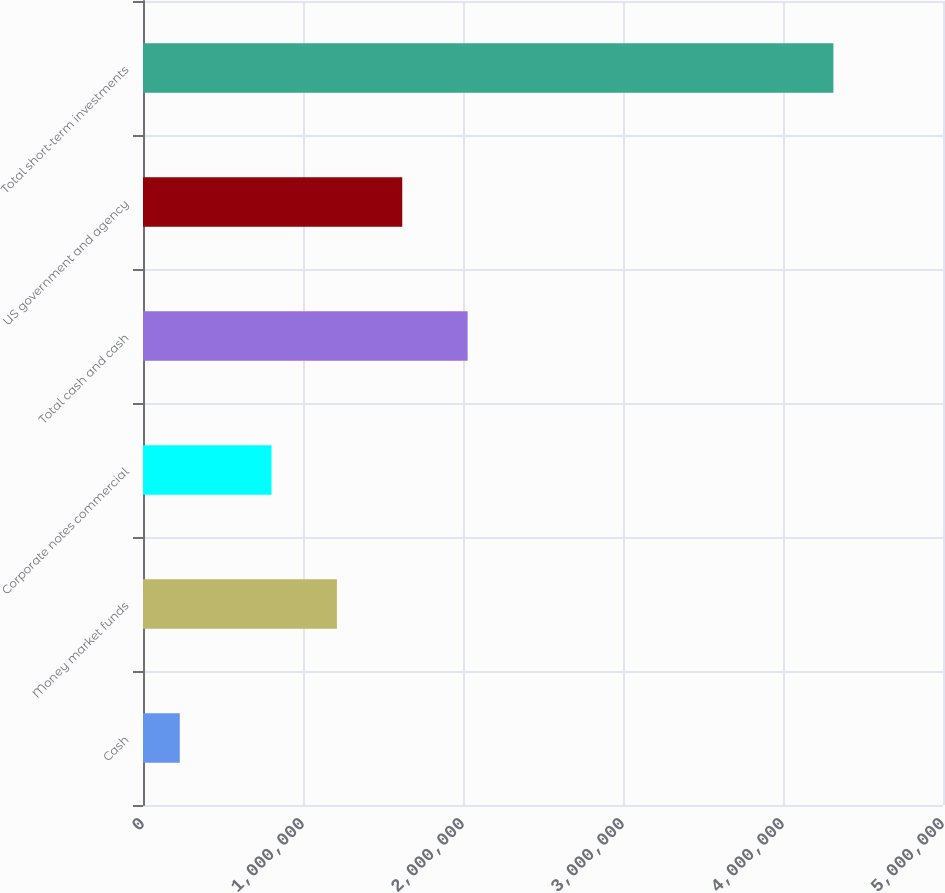Convert chart. <chart><loc_0><loc_0><loc_500><loc_500><bar_chart><fcel>Cash<fcel>Money market funds<fcel>Corporate notes commercial<fcel>Total cash and cash<fcel>US government and agency<fcel>Total short-term investments<nl><fcel>229924<fcel>1.21182e+06<fcel>803314<fcel>2.02882e+06<fcel>1.62032e+06<fcel>4.31496e+06<nl></chart> 